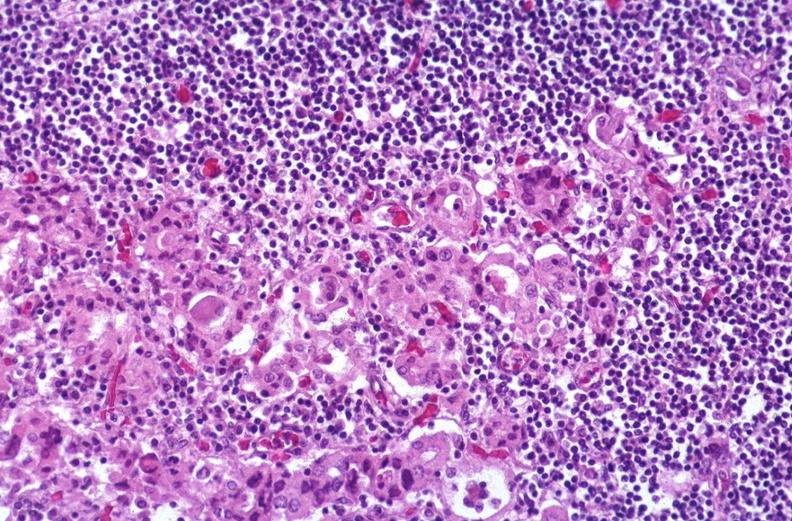what does this image show?
Answer the question using a single word or phrase. Hashimoto 's thyroiditis 